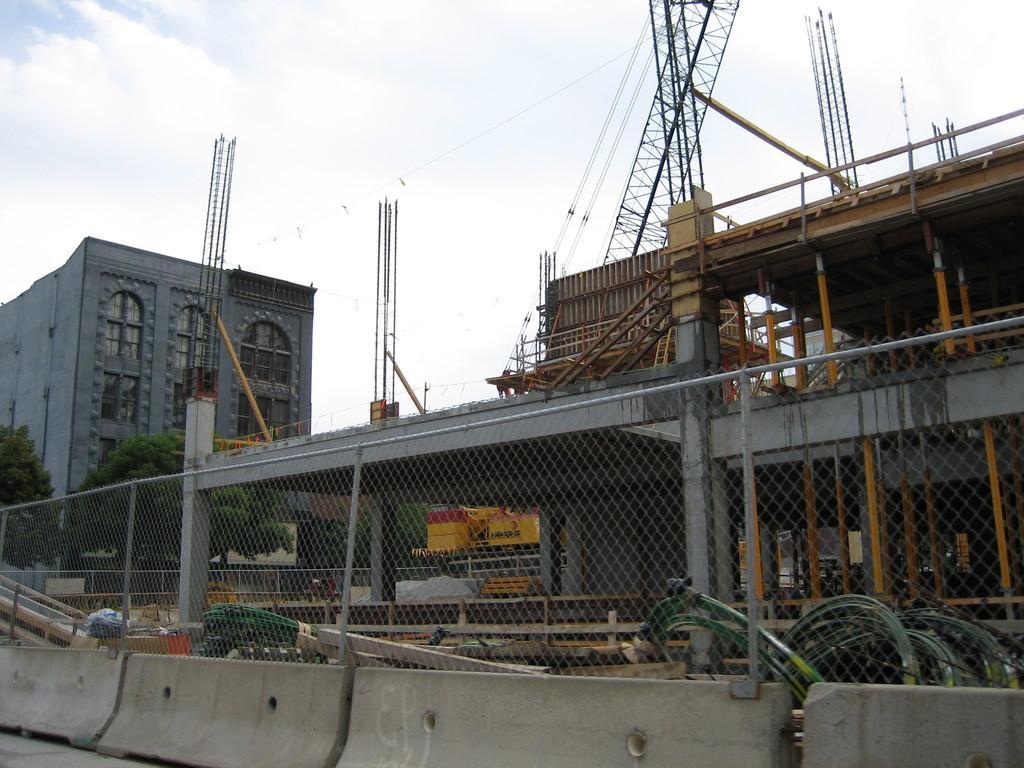Please provide a concise description of this image. In this image there is a fencing, behind the fencing there is a construction, in the background there are trees and a building. 